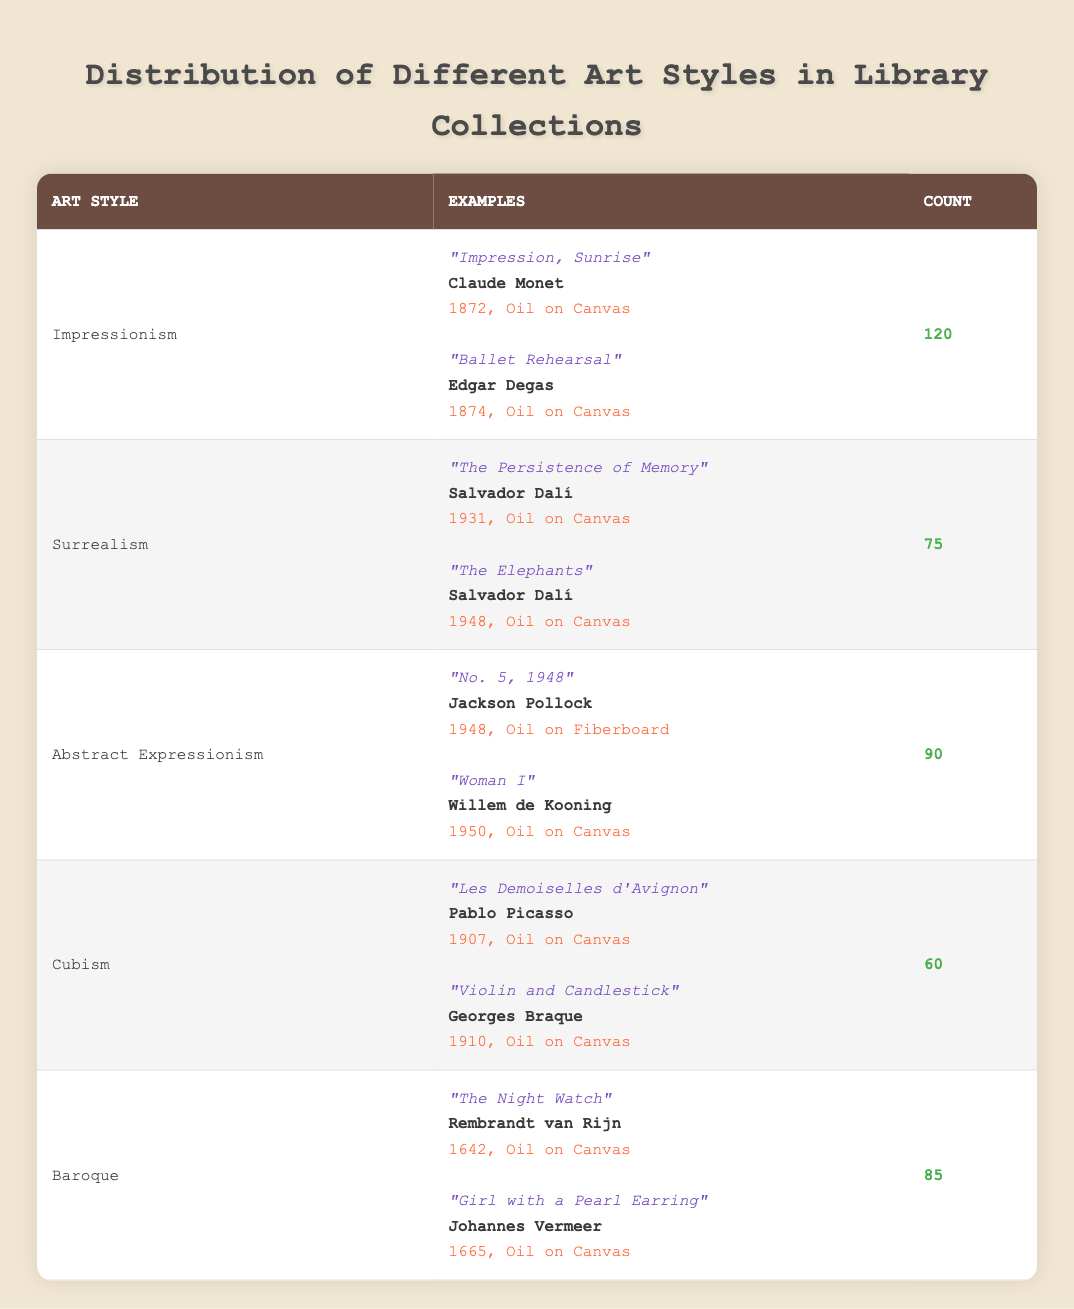What is the art style with the highest count in the library collections? By scanning the table, I can see that "Impressionism" has a count of 120, which is the highest compared to the other art styles listed.
Answer: Impressionism How many examples are listed for the Cubism art style? The table shows that there are two examples listed under the Cubism art style, specifically "Les Demoiselles d'Avignon" and "Violin and Candlestick."
Answer: 2 What is the total count of artworks for the Abstract Expressionism and Baroque styles combined? I will add the counts together: Abstract Expressionism has 90 artworks and Baroque has 85 artworks. Therefore, the total is 90 + 85 = 175.
Answer: 175 Is Surrealism the art style with more than 80 examples in the library collection? The table indicates that Surrealism has a count of 75 artworks, which is not more than 80. Therefore, the statement is false.
Answer: No Which artist created "The Persistence of Memory"? The data shows that "The Persistence of Memory" is an example of Surrealism and is created by Salvador Dalí.
Answer: Salvador Dalí How many total distinct art styles are represented in the library collections? The table lists five different art styles: Impressionism, Surrealism, Abstract Expressionism, Cubism, and Baroque. Therefore, there are a total of 5 distinct art styles.
Answer: 5 Which art style has the least number of examples, and what is the title of one of its artworks? By examining the counts, Cubism has the least number of artworks at 60. An example of an artwork from this style is "Les Demoiselles d'Avignon."
Answer: Cubism, "Les Demoiselles d'Avignon" What is the average count of artworks across the represented art styles? To find the average, I must add up all the counts: 120 (Impressionism) + 75 (Surrealism) + 90 (Abstract Expressionism) + 60 (Cubism) + 85 (Baroque) = 430. Then I divide by the number of styles, which is 5: 430 / 5 = 86.
Answer: 86 Does the library collection contain artworks created by both Claude Monet and Pablo Picasso? Checking the table reveals that Claude Monet is linked to the Impressionism style, while Pablo Picasso is linked to Cubism. Therefore, both artists are represented in the collection.
Answer: Yes 